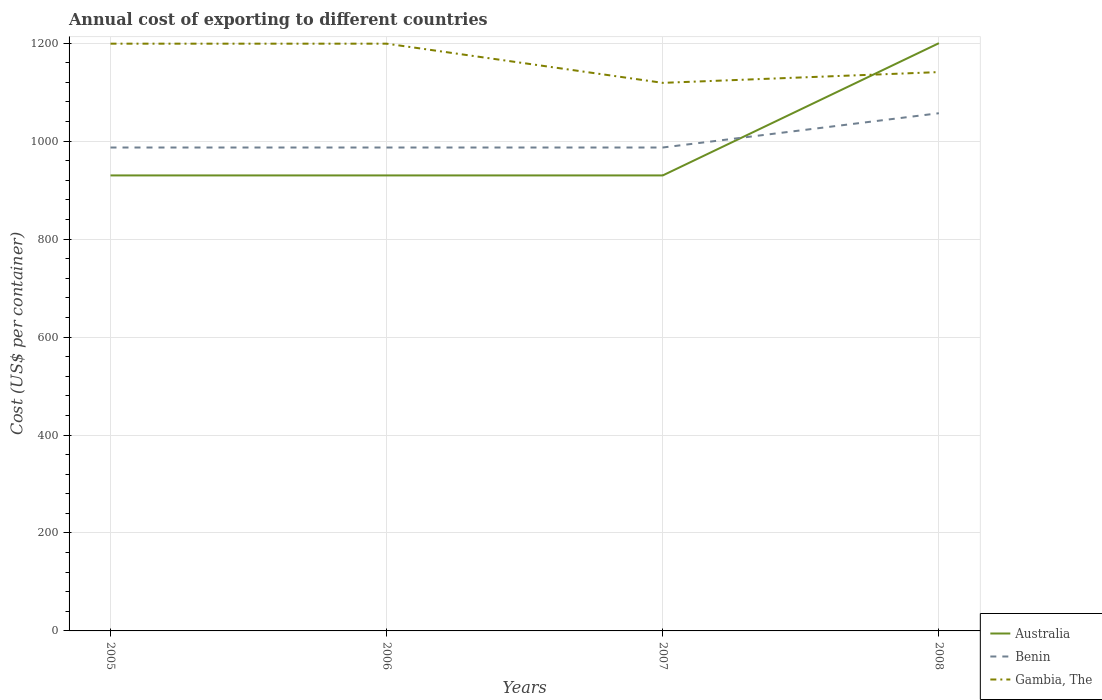How many different coloured lines are there?
Make the answer very short. 3. Does the line corresponding to Gambia, The intersect with the line corresponding to Benin?
Your answer should be very brief. No. Is the number of lines equal to the number of legend labels?
Provide a short and direct response. Yes. Across all years, what is the maximum total annual cost of exporting in Gambia, The?
Offer a terse response. 1119. What is the total total annual cost of exporting in Benin in the graph?
Your answer should be very brief. 0. What is the difference between the highest and the second highest total annual cost of exporting in Gambia, The?
Offer a terse response. 80. What is the difference between the highest and the lowest total annual cost of exporting in Australia?
Provide a short and direct response. 1. Where does the legend appear in the graph?
Your answer should be compact. Bottom right. What is the title of the graph?
Provide a short and direct response. Annual cost of exporting to different countries. What is the label or title of the Y-axis?
Ensure brevity in your answer.  Cost (US$ per container). What is the Cost (US$ per container) of Australia in 2005?
Make the answer very short. 930. What is the Cost (US$ per container) of Benin in 2005?
Your response must be concise. 987. What is the Cost (US$ per container) in Gambia, The in 2005?
Your answer should be compact. 1199. What is the Cost (US$ per container) of Australia in 2006?
Provide a short and direct response. 930. What is the Cost (US$ per container) in Benin in 2006?
Keep it short and to the point. 987. What is the Cost (US$ per container) of Gambia, The in 2006?
Your response must be concise. 1199. What is the Cost (US$ per container) in Australia in 2007?
Provide a short and direct response. 930. What is the Cost (US$ per container) of Benin in 2007?
Keep it short and to the point. 987. What is the Cost (US$ per container) of Gambia, The in 2007?
Make the answer very short. 1119. What is the Cost (US$ per container) in Australia in 2008?
Provide a short and direct response. 1200. What is the Cost (US$ per container) in Benin in 2008?
Your response must be concise. 1057. What is the Cost (US$ per container) of Gambia, The in 2008?
Your response must be concise. 1141. Across all years, what is the maximum Cost (US$ per container) in Australia?
Ensure brevity in your answer.  1200. Across all years, what is the maximum Cost (US$ per container) of Benin?
Your response must be concise. 1057. Across all years, what is the maximum Cost (US$ per container) of Gambia, The?
Provide a short and direct response. 1199. Across all years, what is the minimum Cost (US$ per container) of Australia?
Keep it short and to the point. 930. Across all years, what is the minimum Cost (US$ per container) of Benin?
Provide a succinct answer. 987. Across all years, what is the minimum Cost (US$ per container) in Gambia, The?
Ensure brevity in your answer.  1119. What is the total Cost (US$ per container) of Australia in the graph?
Your answer should be very brief. 3990. What is the total Cost (US$ per container) in Benin in the graph?
Provide a short and direct response. 4018. What is the total Cost (US$ per container) in Gambia, The in the graph?
Provide a short and direct response. 4658. What is the difference between the Cost (US$ per container) in Australia in 2005 and that in 2006?
Offer a terse response. 0. What is the difference between the Cost (US$ per container) in Gambia, The in 2005 and that in 2006?
Give a very brief answer. 0. What is the difference between the Cost (US$ per container) in Australia in 2005 and that in 2007?
Give a very brief answer. 0. What is the difference between the Cost (US$ per container) in Gambia, The in 2005 and that in 2007?
Give a very brief answer. 80. What is the difference between the Cost (US$ per container) of Australia in 2005 and that in 2008?
Keep it short and to the point. -270. What is the difference between the Cost (US$ per container) in Benin in 2005 and that in 2008?
Your answer should be very brief. -70. What is the difference between the Cost (US$ per container) of Gambia, The in 2005 and that in 2008?
Offer a very short reply. 58. What is the difference between the Cost (US$ per container) of Gambia, The in 2006 and that in 2007?
Offer a terse response. 80. What is the difference between the Cost (US$ per container) in Australia in 2006 and that in 2008?
Your answer should be compact. -270. What is the difference between the Cost (US$ per container) in Benin in 2006 and that in 2008?
Keep it short and to the point. -70. What is the difference between the Cost (US$ per container) of Gambia, The in 2006 and that in 2008?
Ensure brevity in your answer.  58. What is the difference between the Cost (US$ per container) of Australia in 2007 and that in 2008?
Make the answer very short. -270. What is the difference between the Cost (US$ per container) of Benin in 2007 and that in 2008?
Your response must be concise. -70. What is the difference between the Cost (US$ per container) in Gambia, The in 2007 and that in 2008?
Give a very brief answer. -22. What is the difference between the Cost (US$ per container) in Australia in 2005 and the Cost (US$ per container) in Benin in 2006?
Ensure brevity in your answer.  -57. What is the difference between the Cost (US$ per container) of Australia in 2005 and the Cost (US$ per container) of Gambia, The in 2006?
Ensure brevity in your answer.  -269. What is the difference between the Cost (US$ per container) in Benin in 2005 and the Cost (US$ per container) in Gambia, The in 2006?
Ensure brevity in your answer.  -212. What is the difference between the Cost (US$ per container) of Australia in 2005 and the Cost (US$ per container) of Benin in 2007?
Keep it short and to the point. -57. What is the difference between the Cost (US$ per container) of Australia in 2005 and the Cost (US$ per container) of Gambia, The in 2007?
Your answer should be compact. -189. What is the difference between the Cost (US$ per container) of Benin in 2005 and the Cost (US$ per container) of Gambia, The in 2007?
Give a very brief answer. -132. What is the difference between the Cost (US$ per container) in Australia in 2005 and the Cost (US$ per container) in Benin in 2008?
Give a very brief answer. -127. What is the difference between the Cost (US$ per container) of Australia in 2005 and the Cost (US$ per container) of Gambia, The in 2008?
Provide a succinct answer. -211. What is the difference between the Cost (US$ per container) of Benin in 2005 and the Cost (US$ per container) of Gambia, The in 2008?
Offer a terse response. -154. What is the difference between the Cost (US$ per container) of Australia in 2006 and the Cost (US$ per container) of Benin in 2007?
Offer a terse response. -57. What is the difference between the Cost (US$ per container) in Australia in 2006 and the Cost (US$ per container) in Gambia, The in 2007?
Ensure brevity in your answer.  -189. What is the difference between the Cost (US$ per container) in Benin in 2006 and the Cost (US$ per container) in Gambia, The in 2007?
Your answer should be compact. -132. What is the difference between the Cost (US$ per container) of Australia in 2006 and the Cost (US$ per container) of Benin in 2008?
Provide a short and direct response. -127. What is the difference between the Cost (US$ per container) of Australia in 2006 and the Cost (US$ per container) of Gambia, The in 2008?
Your answer should be compact. -211. What is the difference between the Cost (US$ per container) of Benin in 2006 and the Cost (US$ per container) of Gambia, The in 2008?
Offer a terse response. -154. What is the difference between the Cost (US$ per container) in Australia in 2007 and the Cost (US$ per container) in Benin in 2008?
Offer a very short reply. -127. What is the difference between the Cost (US$ per container) in Australia in 2007 and the Cost (US$ per container) in Gambia, The in 2008?
Provide a short and direct response. -211. What is the difference between the Cost (US$ per container) of Benin in 2007 and the Cost (US$ per container) of Gambia, The in 2008?
Provide a succinct answer. -154. What is the average Cost (US$ per container) of Australia per year?
Keep it short and to the point. 997.5. What is the average Cost (US$ per container) in Benin per year?
Your response must be concise. 1004.5. What is the average Cost (US$ per container) in Gambia, The per year?
Your answer should be very brief. 1164.5. In the year 2005, what is the difference between the Cost (US$ per container) in Australia and Cost (US$ per container) in Benin?
Your answer should be very brief. -57. In the year 2005, what is the difference between the Cost (US$ per container) in Australia and Cost (US$ per container) in Gambia, The?
Your answer should be compact. -269. In the year 2005, what is the difference between the Cost (US$ per container) in Benin and Cost (US$ per container) in Gambia, The?
Give a very brief answer. -212. In the year 2006, what is the difference between the Cost (US$ per container) in Australia and Cost (US$ per container) in Benin?
Provide a short and direct response. -57. In the year 2006, what is the difference between the Cost (US$ per container) of Australia and Cost (US$ per container) of Gambia, The?
Give a very brief answer. -269. In the year 2006, what is the difference between the Cost (US$ per container) of Benin and Cost (US$ per container) of Gambia, The?
Ensure brevity in your answer.  -212. In the year 2007, what is the difference between the Cost (US$ per container) in Australia and Cost (US$ per container) in Benin?
Ensure brevity in your answer.  -57. In the year 2007, what is the difference between the Cost (US$ per container) of Australia and Cost (US$ per container) of Gambia, The?
Your answer should be very brief. -189. In the year 2007, what is the difference between the Cost (US$ per container) of Benin and Cost (US$ per container) of Gambia, The?
Make the answer very short. -132. In the year 2008, what is the difference between the Cost (US$ per container) of Australia and Cost (US$ per container) of Benin?
Make the answer very short. 143. In the year 2008, what is the difference between the Cost (US$ per container) of Benin and Cost (US$ per container) of Gambia, The?
Your answer should be very brief. -84. What is the ratio of the Cost (US$ per container) in Australia in 2005 to that in 2006?
Your answer should be compact. 1. What is the ratio of the Cost (US$ per container) in Australia in 2005 to that in 2007?
Provide a short and direct response. 1. What is the ratio of the Cost (US$ per container) in Gambia, The in 2005 to that in 2007?
Make the answer very short. 1.07. What is the ratio of the Cost (US$ per container) of Australia in 2005 to that in 2008?
Ensure brevity in your answer.  0.78. What is the ratio of the Cost (US$ per container) of Benin in 2005 to that in 2008?
Your answer should be compact. 0.93. What is the ratio of the Cost (US$ per container) of Gambia, The in 2005 to that in 2008?
Offer a terse response. 1.05. What is the ratio of the Cost (US$ per container) in Benin in 2006 to that in 2007?
Offer a very short reply. 1. What is the ratio of the Cost (US$ per container) of Gambia, The in 2006 to that in 2007?
Provide a succinct answer. 1.07. What is the ratio of the Cost (US$ per container) of Australia in 2006 to that in 2008?
Make the answer very short. 0.78. What is the ratio of the Cost (US$ per container) in Benin in 2006 to that in 2008?
Offer a terse response. 0.93. What is the ratio of the Cost (US$ per container) in Gambia, The in 2006 to that in 2008?
Provide a short and direct response. 1.05. What is the ratio of the Cost (US$ per container) in Australia in 2007 to that in 2008?
Make the answer very short. 0.78. What is the ratio of the Cost (US$ per container) of Benin in 2007 to that in 2008?
Provide a short and direct response. 0.93. What is the ratio of the Cost (US$ per container) in Gambia, The in 2007 to that in 2008?
Offer a terse response. 0.98. What is the difference between the highest and the second highest Cost (US$ per container) of Australia?
Provide a succinct answer. 270. What is the difference between the highest and the second highest Cost (US$ per container) in Gambia, The?
Keep it short and to the point. 0. What is the difference between the highest and the lowest Cost (US$ per container) in Australia?
Provide a short and direct response. 270. What is the difference between the highest and the lowest Cost (US$ per container) of Gambia, The?
Provide a succinct answer. 80. 